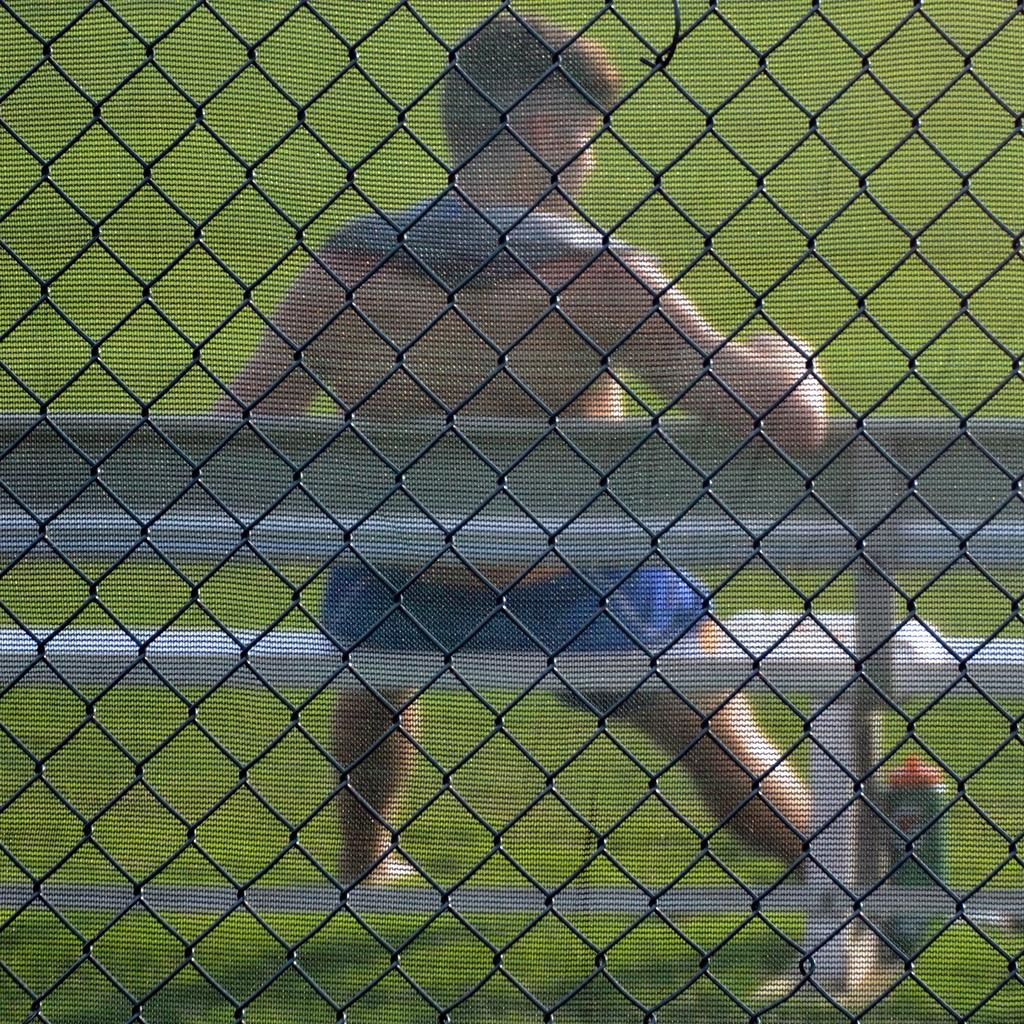What can be seen in the image that separates different areas? There is a fence in the image. Can you describe the setting in the background of the image? There is a man sitting on a bench in the background of the image. What type of vegetation is present on the ground in the image? There is green color grass on the ground in the image. What type of game is being played on the grass in the image? There is no game present in the image; it features a fence, a man sitting on a bench, and green color grass on the ground. 